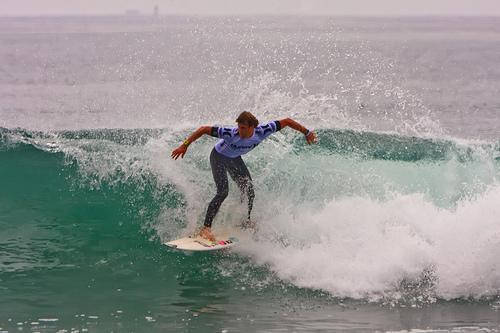How many people are in the photo?
Give a very brief answer. 1. 